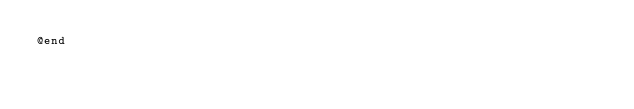<code> <loc_0><loc_0><loc_500><loc_500><_C_>@end
</code> 